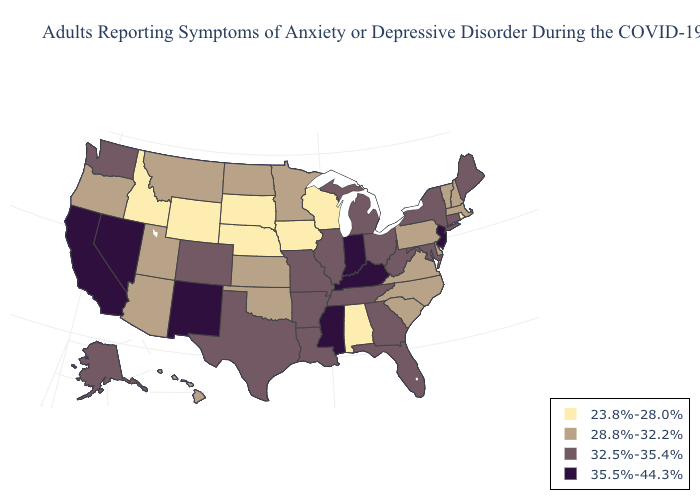Does Indiana have the highest value in the USA?
Answer briefly. Yes. What is the lowest value in the Northeast?
Write a very short answer. 23.8%-28.0%. What is the lowest value in states that border Mississippi?
Answer briefly. 23.8%-28.0%. What is the value of New Mexico?
Quick response, please. 35.5%-44.3%. Name the states that have a value in the range 28.8%-32.2%?
Write a very short answer. Arizona, Delaware, Hawaii, Kansas, Massachusetts, Minnesota, Montana, New Hampshire, North Carolina, North Dakota, Oklahoma, Oregon, Pennsylvania, South Carolina, Utah, Vermont, Virginia. Does New Jersey have the highest value in the USA?
Write a very short answer. Yes. Among the states that border Virginia , does Tennessee have the lowest value?
Quick response, please. No. Which states have the highest value in the USA?
Quick response, please. California, Indiana, Kentucky, Mississippi, Nevada, New Jersey, New Mexico. Does Iowa have the lowest value in the USA?
Be succinct. Yes. Name the states that have a value in the range 28.8%-32.2%?
Be succinct. Arizona, Delaware, Hawaii, Kansas, Massachusetts, Minnesota, Montana, New Hampshire, North Carolina, North Dakota, Oklahoma, Oregon, Pennsylvania, South Carolina, Utah, Vermont, Virginia. Name the states that have a value in the range 32.5%-35.4%?
Keep it brief. Alaska, Arkansas, Colorado, Connecticut, Florida, Georgia, Illinois, Louisiana, Maine, Maryland, Michigan, Missouri, New York, Ohio, Tennessee, Texas, Washington, West Virginia. Among the states that border Maryland , does West Virginia have the lowest value?
Concise answer only. No. Does New Mexico have a lower value than Massachusetts?
Answer briefly. No. What is the highest value in the USA?
Write a very short answer. 35.5%-44.3%. What is the value of Wisconsin?
Give a very brief answer. 23.8%-28.0%. 